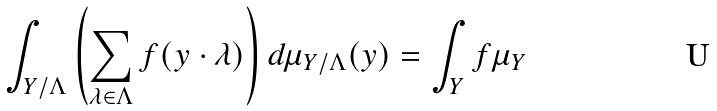<formula> <loc_0><loc_0><loc_500><loc_500>\int _ { Y / \Lambda } \left ( \sum _ { \lambda \in \Lambda } f ( y \cdot \lambda ) \right ) d \mu _ { Y / \Lambda } ( y ) = \int _ { Y } f \mu _ { Y }</formula> 